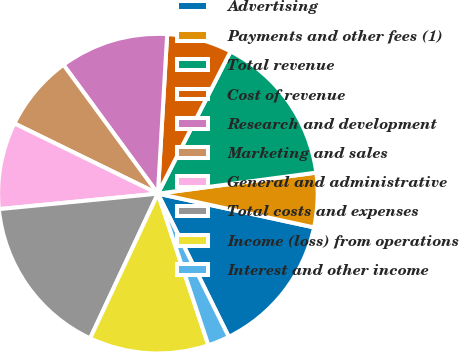Convert chart. <chart><loc_0><loc_0><loc_500><loc_500><pie_chart><fcel>Advertising<fcel>Payments and other fees (1)<fcel>Total revenue<fcel>Cost of revenue<fcel>Research and development<fcel>Marketing and sales<fcel>General and administrative<fcel>Total costs and expenses<fcel>Income (loss) from operations<fcel>Interest and other income<nl><fcel>14.29%<fcel>5.49%<fcel>15.38%<fcel>6.59%<fcel>10.99%<fcel>7.69%<fcel>8.79%<fcel>16.48%<fcel>12.09%<fcel>2.2%<nl></chart> 